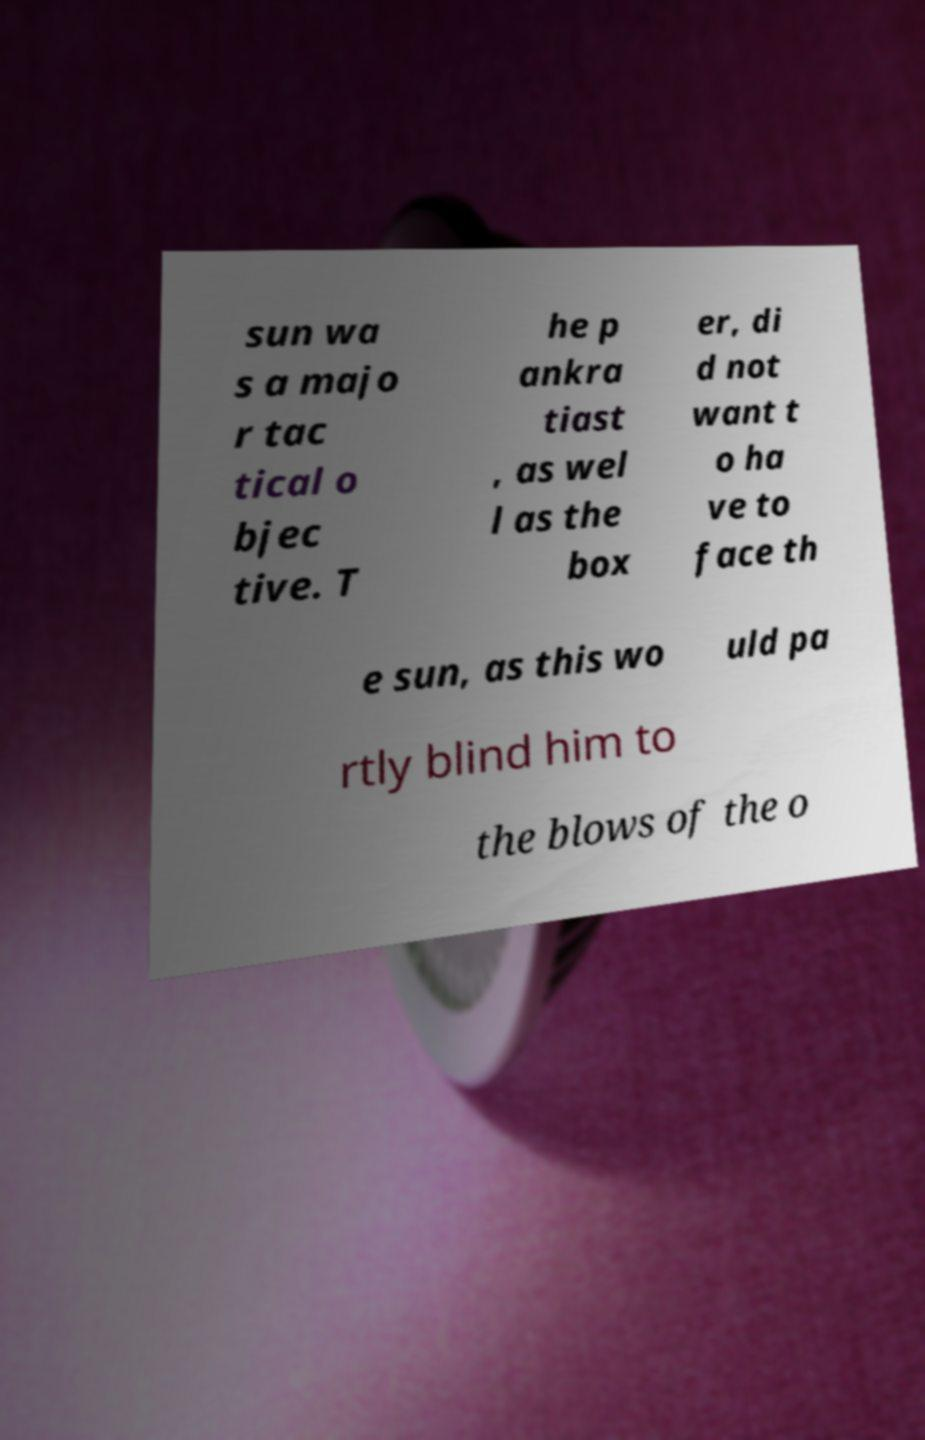What messages or text are displayed in this image? I need them in a readable, typed format. sun wa s a majo r tac tical o bjec tive. T he p ankra tiast , as wel l as the box er, di d not want t o ha ve to face th e sun, as this wo uld pa rtly blind him to the blows of the o 